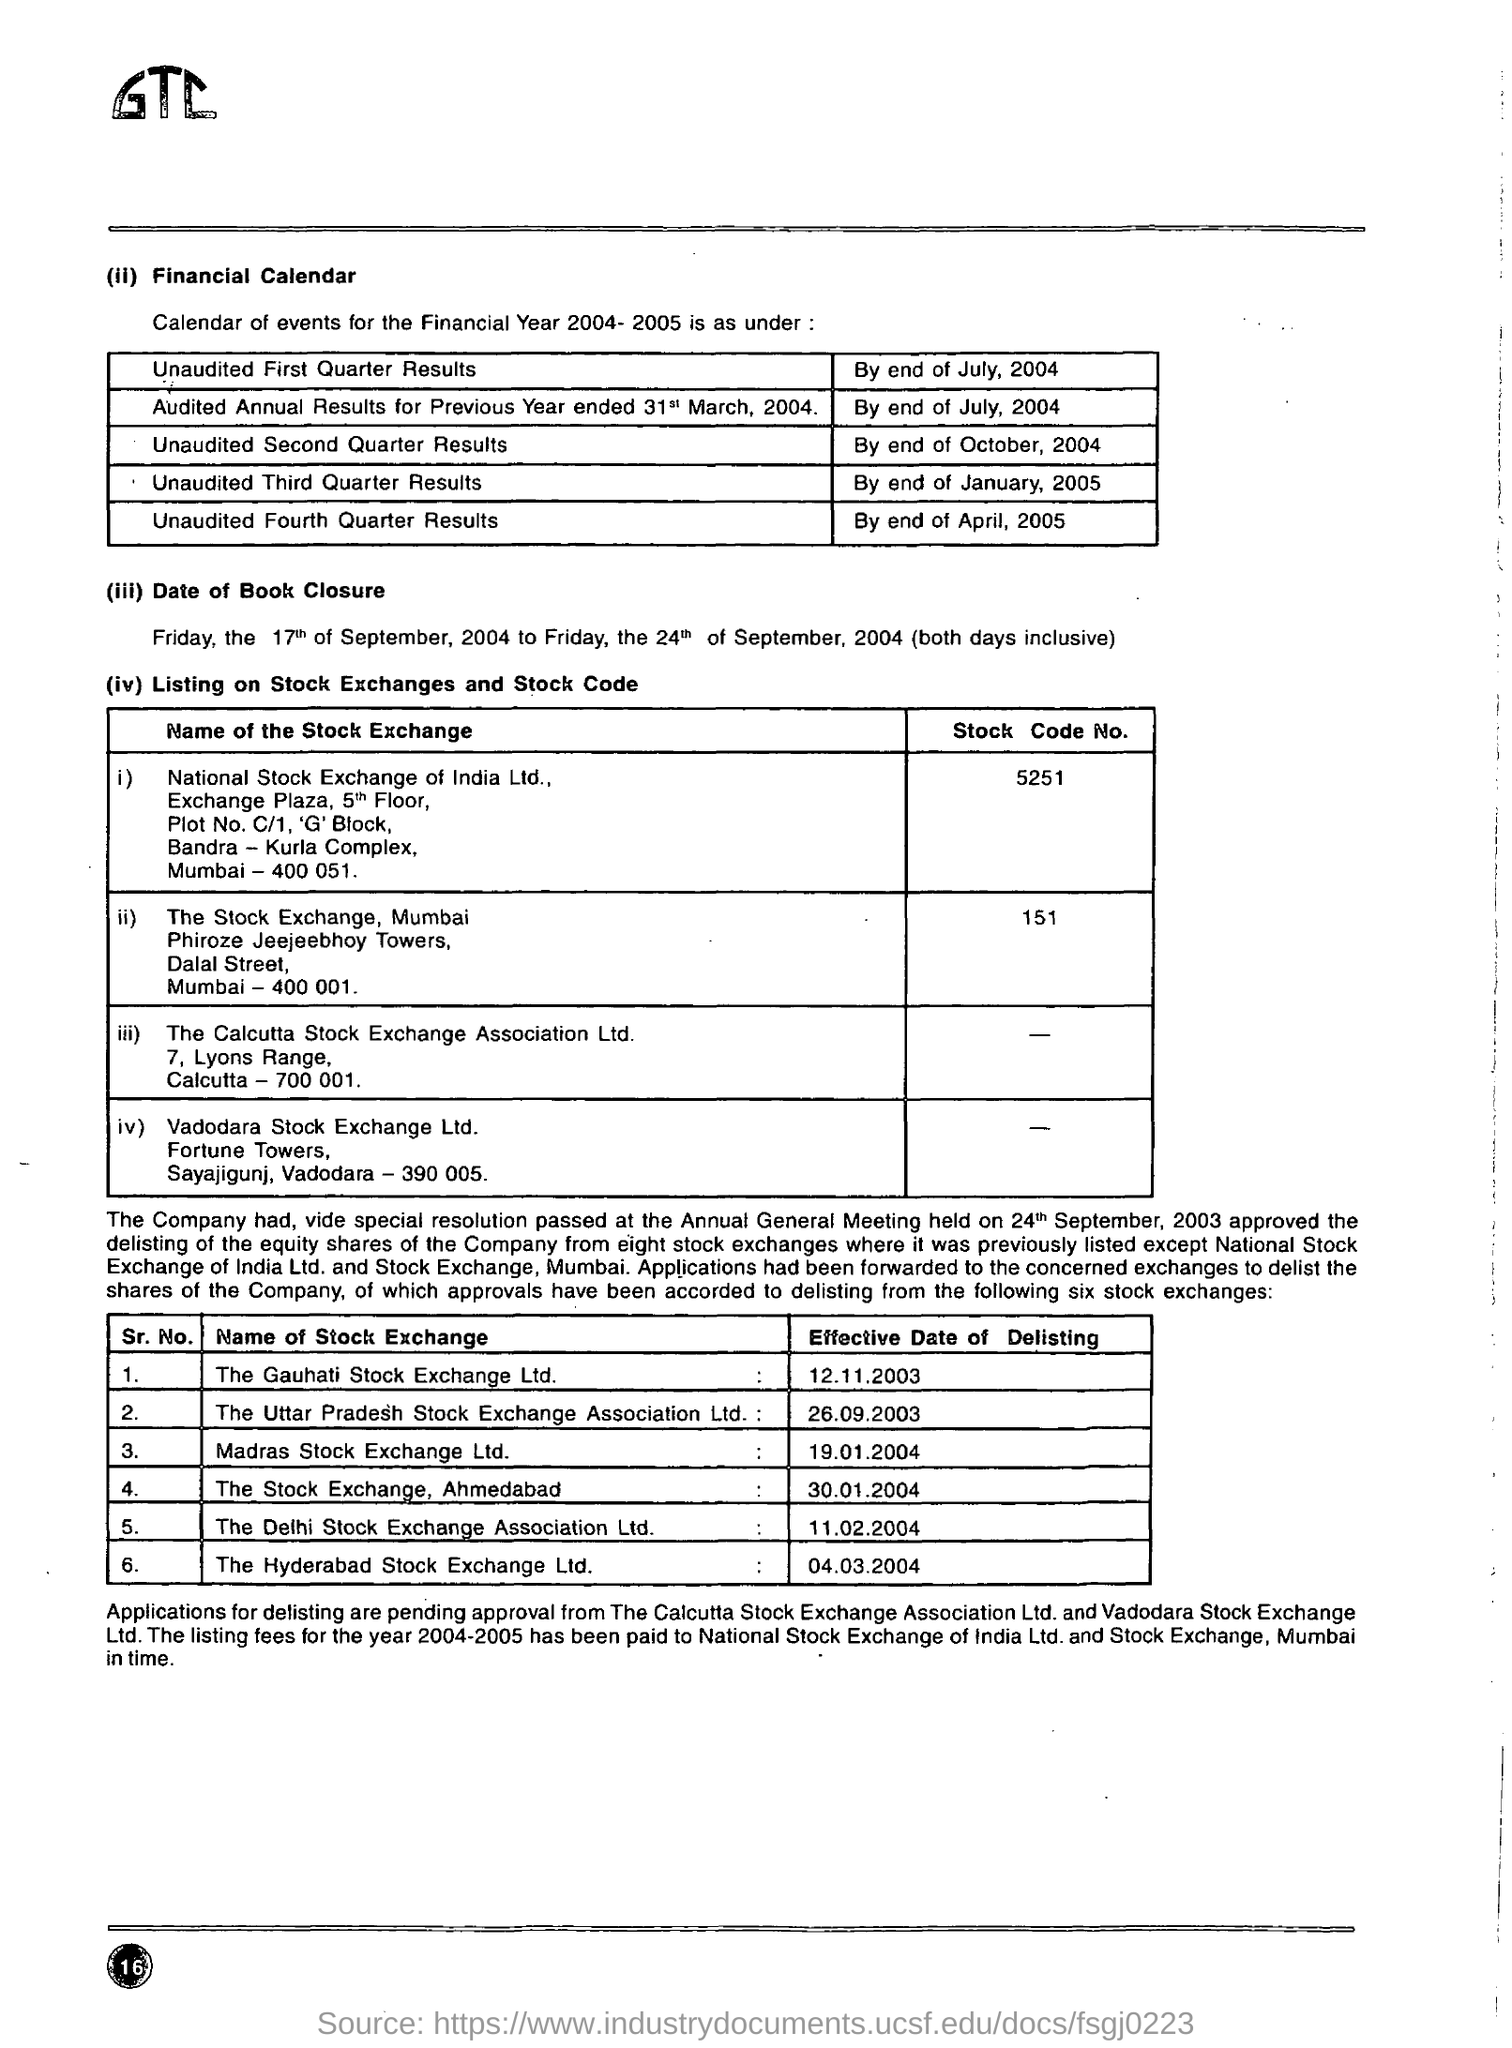Indicate a few pertinent items in this graphic. The stock code number for the stock exchange in Mumbai is 151. The unaudited third quarter results are expected to be declared by the end of January 2005. The effective date of delisting for Hyderabad Stock Exchange Ltd. was March 4, 2004. The unaudited fourth quarter results will be declared by the end of April 2005. The national stock exchange of India Limited's stock code number is 5251. 